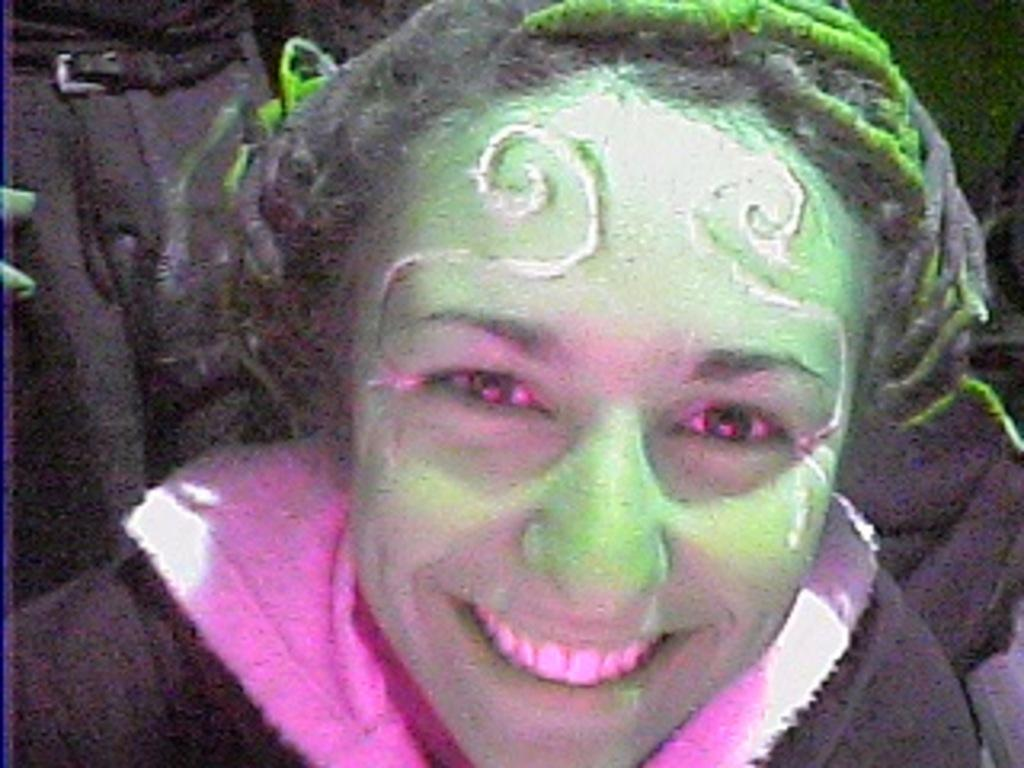What is the main subject of the image? There is a person in the image. What is the person doing in the image? The person is smiling. What can be observed about the background of the image? The background of the image is dark. What type of creature is making the person laugh in the image? There is no creature present in the image, and the person is not laughing; they are smiling. What is the person using to carry the crate in the image? There is no crate present in the image. 